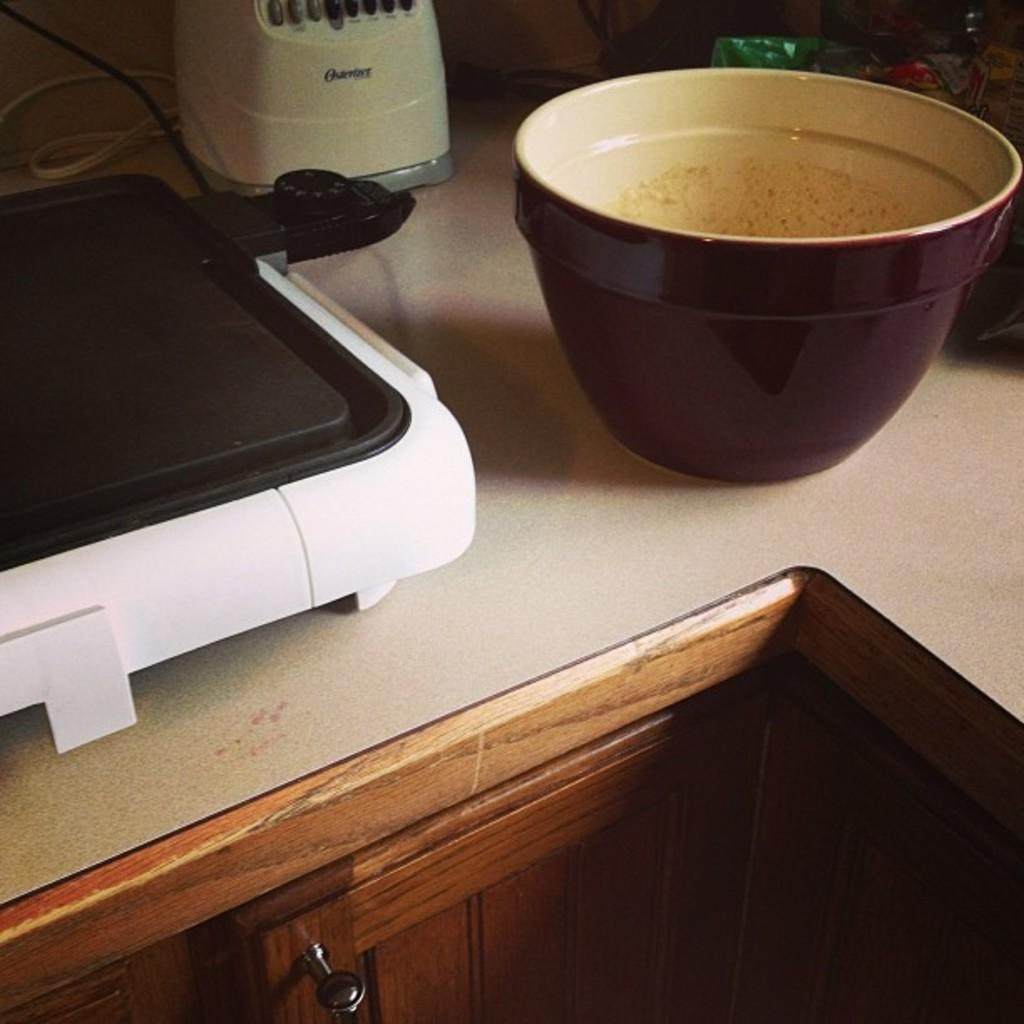<image>
Describe the image concisely. A kitchen counter top with an Oster food blender. 